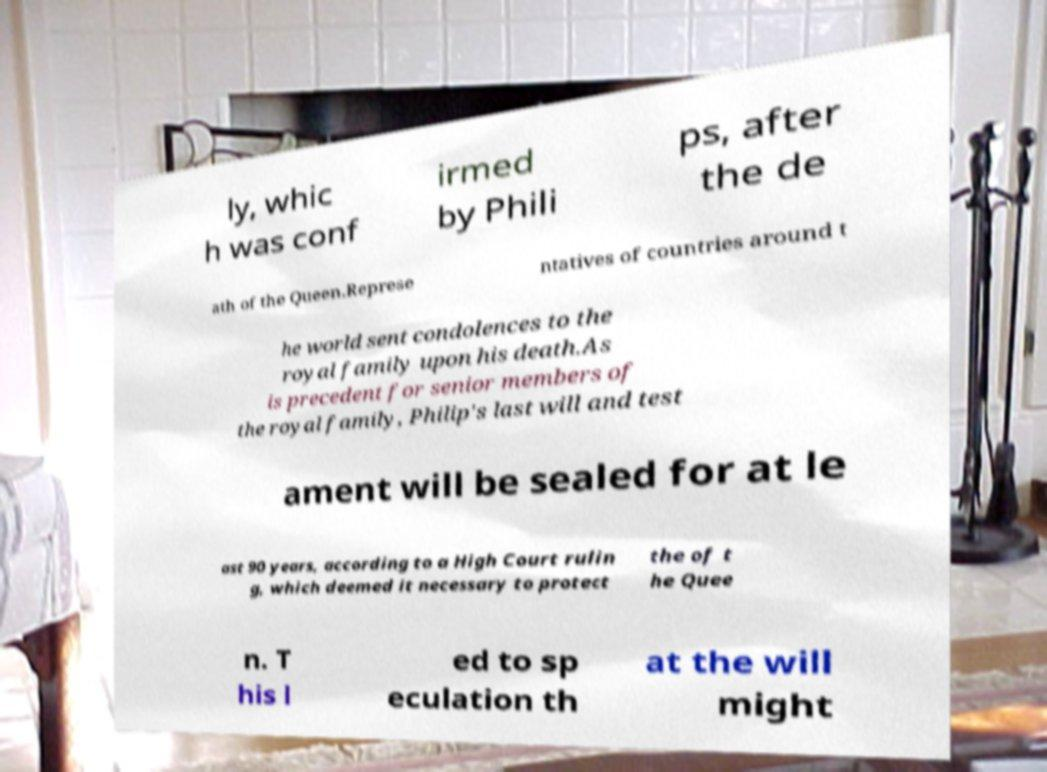Can you accurately transcribe the text from the provided image for me? ly, whic h was conf irmed by Phili ps, after the de ath of the Queen.Represe ntatives of countries around t he world sent condolences to the royal family upon his death.As is precedent for senior members of the royal family, Philip's last will and test ament will be sealed for at le ast 90 years, according to a High Court rulin g, which deemed it necessary to protect the of t he Quee n. T his l ed to sp eculation th at the will might 